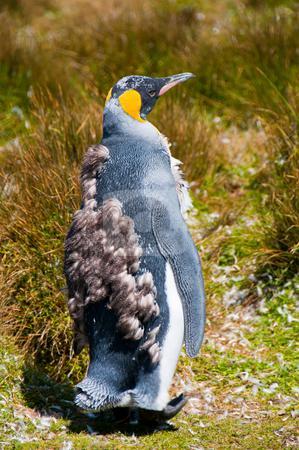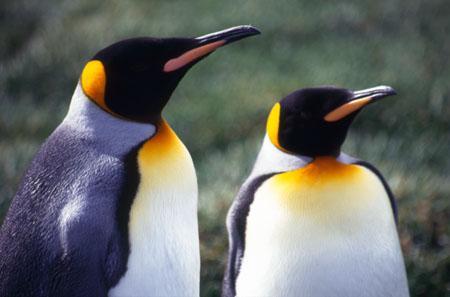The first image is the image on the left, the second image is the image on the right. Evaluate the accuracy of this statement regarding the images: "Two penguins stand together in the image on the right.". Is it true? Answer yes or no. Yes. The first image is the image on the left, the second image is the image on the right. Given the left and right images, does the statement "An image shows only a moulting penguin with patchy brown feathers." hold true? Answer yes or no. Yes. 